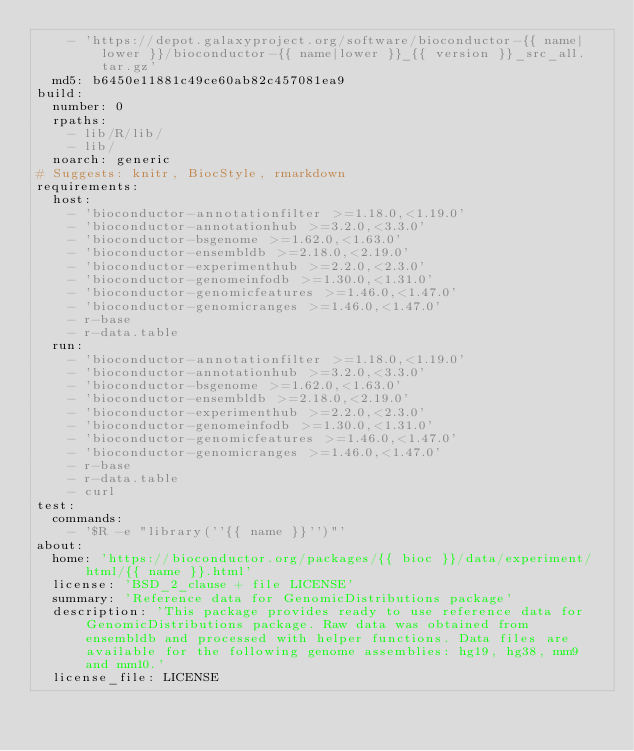Convert code to text. <code><loc_0><loc_0><loc_500><loc_500><_YAML_>    - 'https://depot.galaxyproject.org/software/bioconductor-{{ name|lower }}/bioconductor-{{ name|lower }}_{{ version }}_src_all.tar.gz'
  md5: b6450e11881c49ce60ab82c457081ea9
build:
  number: 0
  rpaths:
    - lib/R/lib/
    - lib/
  noarch: generic
# Suggests: knitr, BiocStyle, rmarkdown
requirements:
  host:
    - 'bioconductor-annotationfilter >=1.18.0,<1.19.0'
    - 'bioconductor-annotationhub >=3.2.0,<3.3.0'
    - 'bioconductor-bsgenome >=1.62.0,<1.63.0'
    - 'bioconductor-ensembldb >=2.18.0,<2.19.0'
    - 'bioconductor-experimenthub >=2.2.0,<2.3.0'
    - 'bioconductor-genomeinfodb >=1.30.0,<1.31.0'
    - 'bioconductor-genomicfeatures >=1.46.0,<1.47.0'
    - 'bioconductor-genomicranges >=1.46.0,<1.47.0'
    - r-base
    - r-data.table
  run:
    - 'bioconductor-annotationfilter >=1.18.0,<1.19.0'
    - 'bioconductor-annotationhub >=3.2.0,<3.3.0'
    - 'bioconductor-bsgenome >=1.62.0,<1.63.0'
    - 'bioconductor-ensembldb >=2.18.0,<2.19.0'
    - 'bioconductor-experimenthub >=2.2.0,<2.3.0'
    - 'bioconductor-genomeinfodb >=1.30.0,<1.31.0'
    - 'bioconductor-genomicfeatures >=1.46.0,<1.47.0'
    - 'bioconductor-genomicranges >=1.46.0,<1.47.0'
    - r-base
    - r-data.table
    - curl
test:
  commands:
    - '$R -e "library(''{{ name }}'')"'
about:
  home: 'https://bioconductor.org/packages/{{ bioc }}/data/experiment/html/{{ name }}.html'
  license: 'BSD_2_clause + file LICENSE'
  summary: 'Reference data for GenomicDistributions package'
  description: 'This package provides ready to use reference data for GenomicDistributions package. Raw data was obtained from ensembldb and processed with helper functions. Data files are available for the following genome assemblies: hg19, hg38, mm9 and mm10.'
  license_file: LICENSE

</code> 